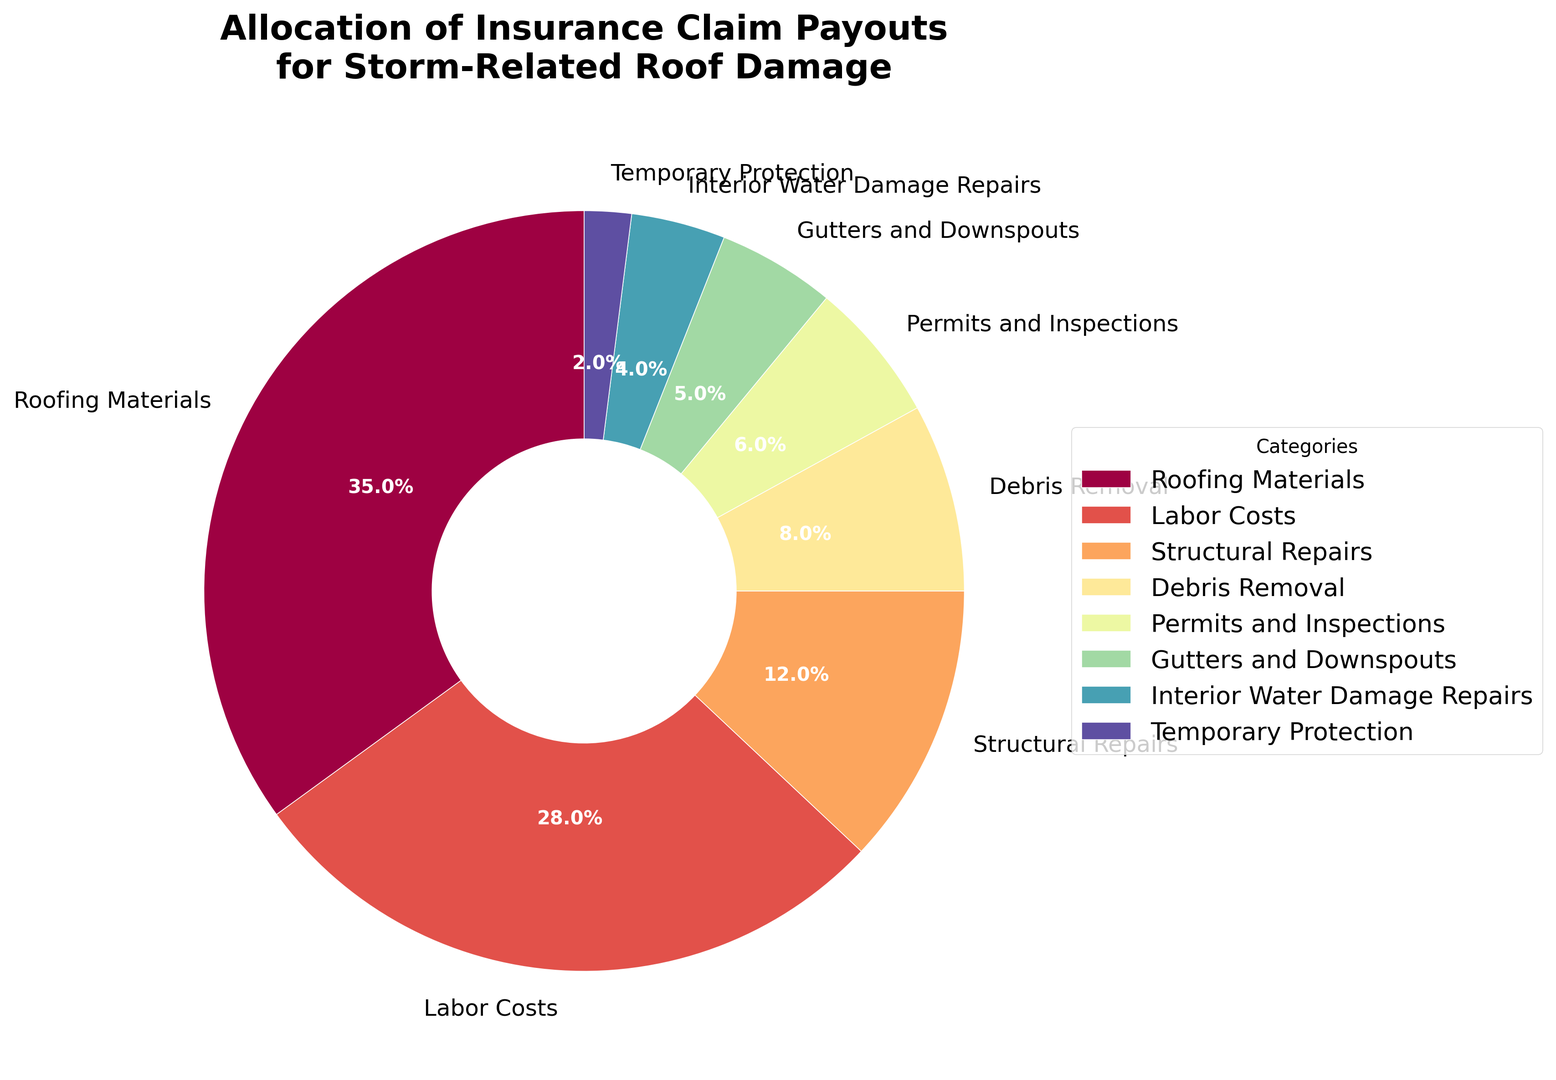What is the largest allocation category in the insurance claim payouts? The largest allocation category can be identified by finding the category with the highest percentage. From the pie chart, "Roofing Materials" has the largest allocation with 35%.
Answer: Roofing Materials How much more is allocated to Roofing Materials compared to Labor Costs? To find how much more is allocated to Roofing Materials than to Labor Costs, subtract the percentage for Labor Costs from the percentage for Roofing Materials. 35% (Roofing Materials) - 28% (Labor Costs) = 7%.
Answer: 7% What is the combined percentage for Structural Repairs and Gutters and Downspouts? To find the combined percentage, add the percentages for Structural Repairs and Gutters and Downspouts. 12% (Structural Repairs) + 5% (Gutters and Downspouts) = 17%.
Answer: 17% Which category has the smallest allocation, and what is its percentage? The category with the smallest allocation can be identified by finding the category with the lowest percentage. From the pie chart, "Temporary Protection" has the smallest allocation with 2%.
Answer: Temporary Protection, 2% Do permits and inspections receive more allocation than debris removal? Comparing the percentages for both Permits and Inspections (6%) and Debris Removal (8%) shows that Debris Removal has a greater allocation.
Answer: No What is the total percentage allocated to categories that involve exterior work (Roofing Materials, Labor Costs, Gutters and Downspouts)? Add the percentages for Roofing Materials (35%), Labor Costs (28%), and Gutters and Downspouts (5%). 35% + 28% + 5% = 68%.
Answer: 68% How does the allocation to Interior Water Damage Repairs compare to Temporary Protection? Compare the percentages for Interior Water Damage Repairs (4%) and Temporary Protection (2%). Interior Water Damage Repairs has a larger allocation.
Answer: Interior Water Damage Repairs has a larger allocation What is the difference in allocation between Debris Removal and Structural Repairs? Subtract the percentage for Structural Repairs from the percentage for Debris Removal. 12% (Structural Repairs) - 8% (Debris Removal) = 4%.
Answer: 4% Are there more funds allocated to Labor Costs or to all categories under 10% combined? First, list all categories under 10%: Structural Repairs (12%), Debris Removal (8%), Permits and Inspections (6%), Gutters and Downspouts (5%), Interior Water Damage Repairs (4%), Temporary Protection (2%). Sum the percentages for these categories: 8% + 6% + 5% + 4% + 2% = 25%, which is less than 28% for Labor Costs.
Answer: Labor Costs What percentage of the payout is spent on Licensing and Inspection compared to all other categories combined? The percentage for Permits and Inspections is 6%. To find the percentage for all other categories, subtract 6% from 100%. 100% - 6% = 94%. Permits and Inspections make up 6% of the payout as compared to 94% for all other categories combined.
Answer: 6% compared to 94% 